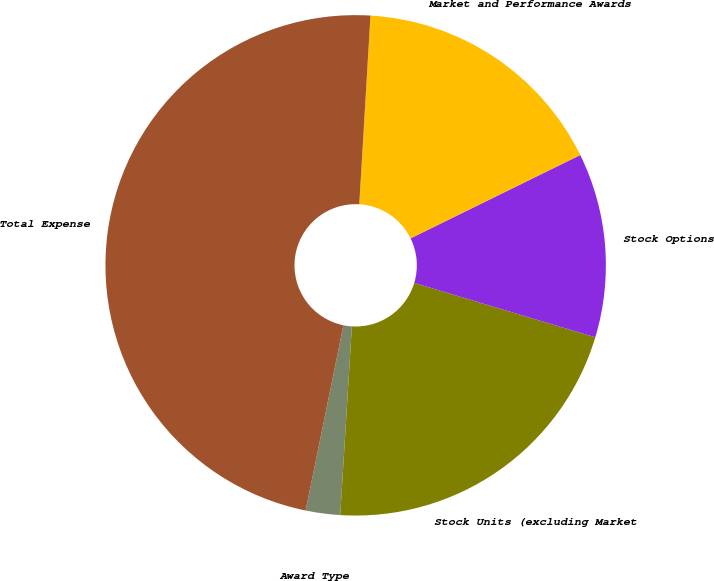<chart> <loc_0><loc_0><loc_500><loc_500><pie_chart><fcel>Award Type<fcel>Stock Units (excluding Market<fcel>Stock Options<fcel>Market and Performance Awards<fcel>Total Expense<nl><fcel>2.22%<fcel>21.34%<fcel>11.91%<fcel>16.79%<fcel>47.74%<nl></chart> 